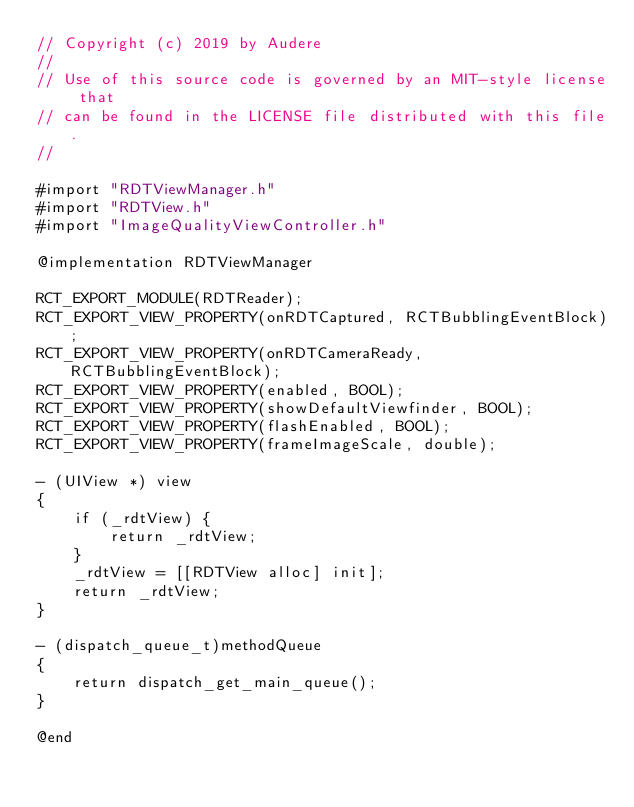<code> <loc_0><loc_0><loc_500><loc_500><_ObjectiveC_>// Copyright (c) 2019 by Audere
//
// Use of this source code is governed by an MIT-style license that
// can be found in the LICENSE file distributed with this file.
//

#import "RDTViewManager.h"
#import "RDTView.h"
#import "ImageQualityViewController.h"

@implementation RDTViewManager

RCT_EXPORT_MODULE(RDTReader);
RCT_EXPORT_VIEW_PROPERTY(onRDTCaptured, RCTBubblingEventBlock);
RCT_EXPORT_VIEW_PROPERTY(onRDTCameraReady, RCTBubblingEventBlock);
RCT_EXPORT_VIEW_PROPERTY(enabled, BOOL);
RCT_EXPORT_VIEW_PROPERTY(showDefaultViewfinder, BOOL);
RCT_EXPORT_VIEW_PROPERTY(flashEnabled, BOOL);
RCT_EXPORT_VIEW_PROPERTY(frameImageScale, double);

- (UIView *) view
{
    if (_rdtView) {
        return _rdtView;
    }
    _rdtView = [[RDTView alloc] init];
    return _rdtView;
}

- (dispatch_queue_t)methodQueue
{
    return dispatch_get_main_queue();
}

@end
</code> 